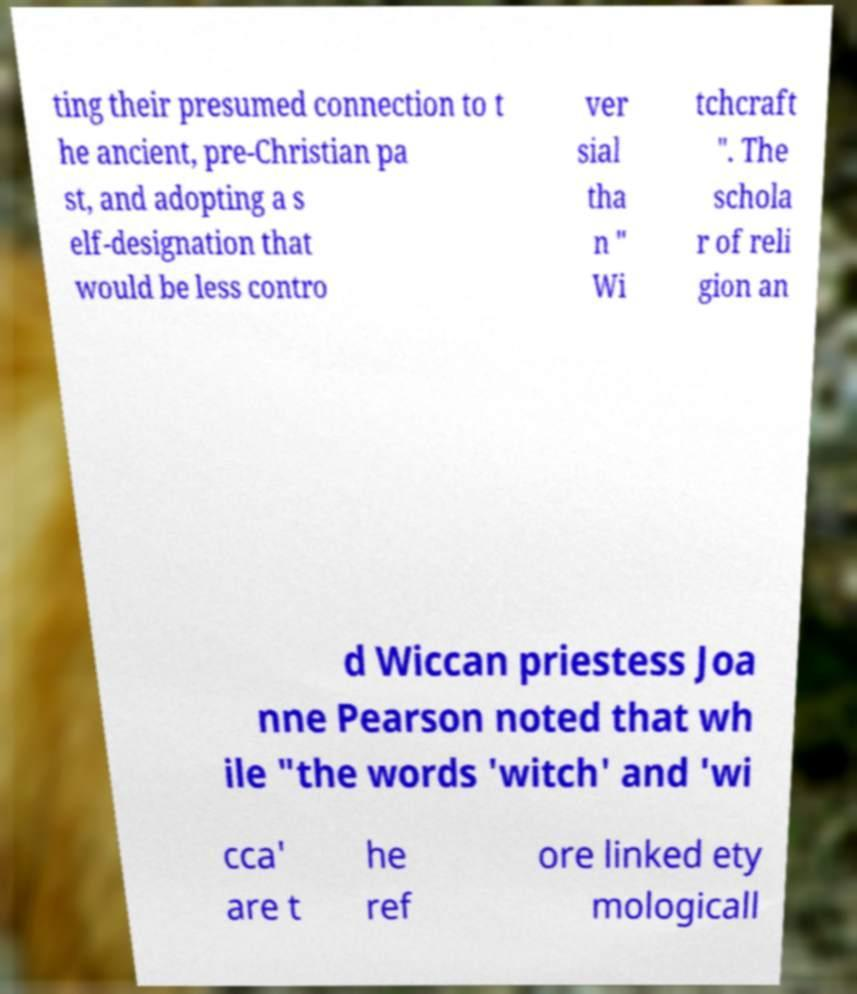What messages or text are displayed in this image? I need them in a readable, typed format. ting their presumed connection to t he ancient, pre-Christian pa st, and adopting a s elf-designation that would be less contro ver sial tha n " Wi tchcraft ". The schola r of reli gion an d Wiccan priestess Joa nne Pearson noted that wh ile "the words 'witch' and 'wi cca' are t he ref ore linked ety mologicall 